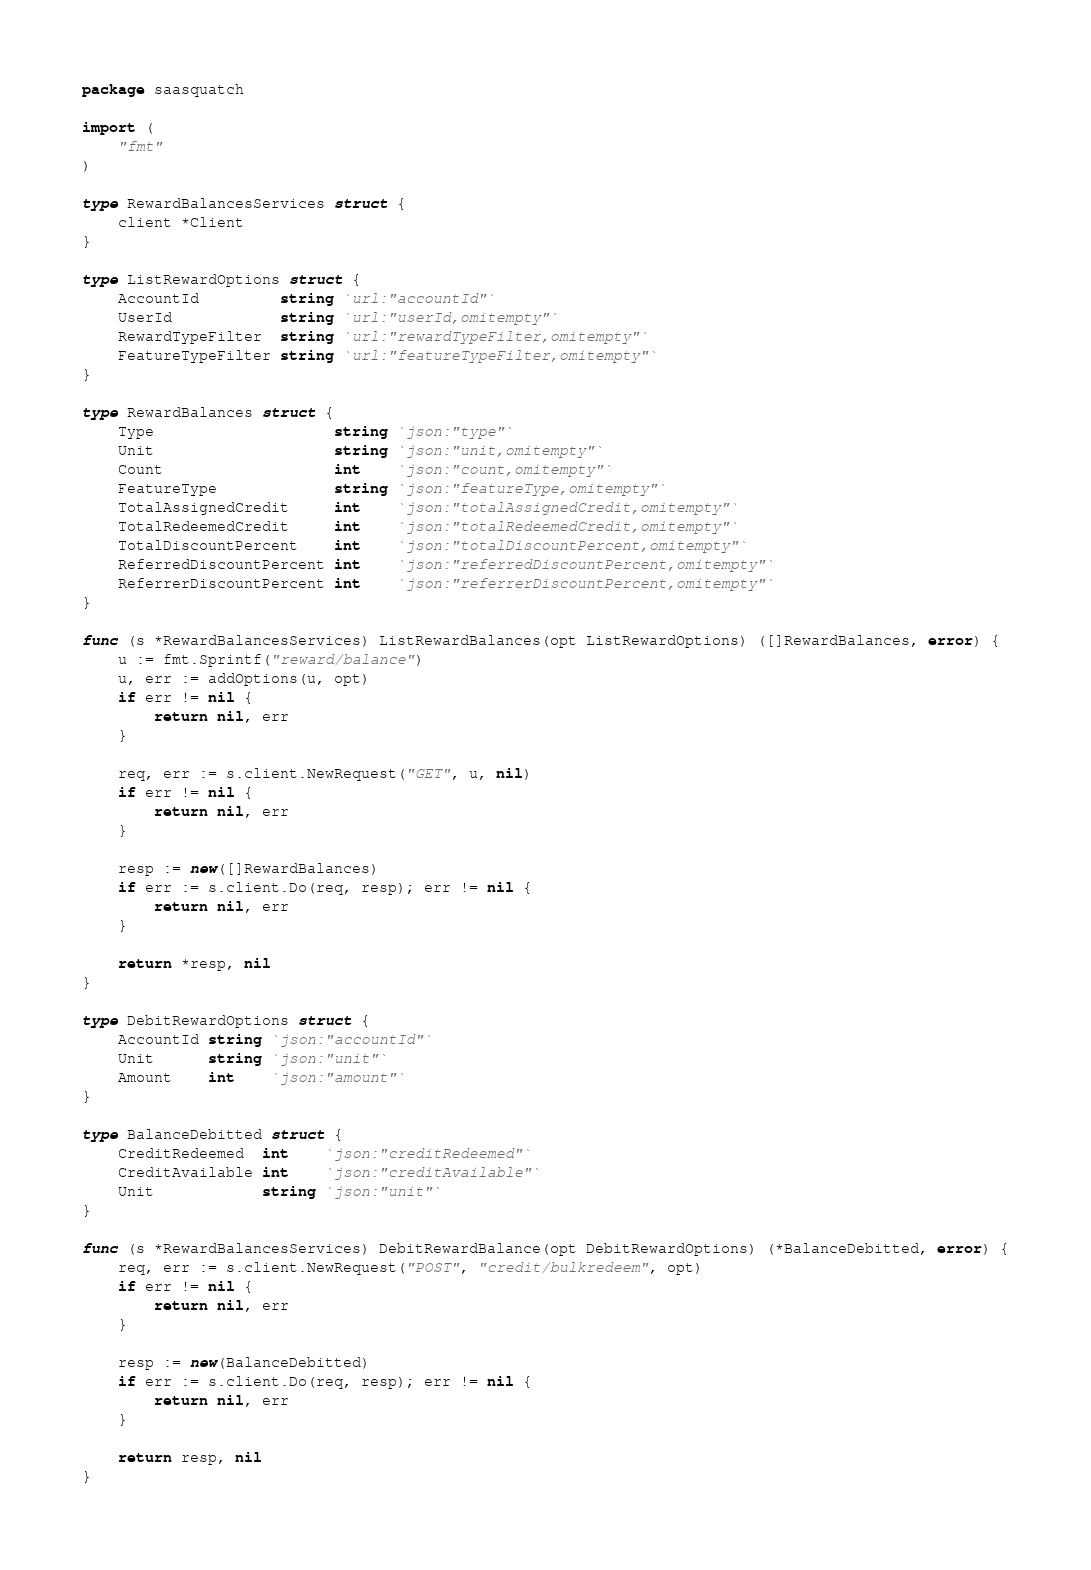Convert code to text. <code><loc_0><loc_0><loc_500><loc_500><_Go_>package saasquatch

import (
	"fmt"
)

type RewardBalancesServices struct {
	client *Client
}

type ListRewardOptions struct {
	AccountId         string `url:"accountId"`
	UserId            string `url:"userId,omitempty"`
	RewardTypeFilter  string `url:"rewardTypeFilter,omitempty"`
	FeatureTypeFilter string `url:"featureTypeFilter,omitempty"`
}

type RewardBalances struct {
	Type                    string `json:"type"`
	Unit                    string `json:"unit,omitempty"`
	Count                   int    `json:"count,omitempty"`
	FeatureType             string `json:"featureType,omitempty"`
	TotalAssignedCredit     int    `json:"totalAssignedCredit,omitempty"`
	TotalRedeemedCredit     int    `json:"totalRedeemedCredit,omitempty"`
	TotalDiscountPercent    int    `json:"totalDiscountPercent,omitempty"`
	ReferredDiscountPercent int    `json:"referredDiscountPercent,omitempty"`
	ReferrerDiscountPercent int    `json:"referrerDiscountPercent,omitempty"`
}

func (s *RewardBalancesServices) ListRewardBalances(opt ListRewardOptions) ([]RewardBalances, error) {
	u := fmt.Sprintf("reward/balance")
	u, err := addOptions(u, opt)
	if err != nil {
		return nil, err
	}

	req, err := s.client.NewRequest("GET", u, nil)
	if err != nil {
		return nil, err
	}

	resp := new([]RewardBalances)
	if err := s.client.Do(req, resp); err != nil {
		return nil, err
	}

	return *resp, nil
}

type DebitRewardOptions struct {
	AccountId string `json:"accountId"`
	Unit      string `json:"unit"`
	Amount    int    `json:"amount"`
}

type BalanceDebitted struct {
	CreditRedeemed  int    `json:"creditRedeemed"`
	CreditAvailable int    `json:"creditAvailable"`
	Unit            string `json:"unit"`
}

func (s *RewardBalancesServices) DebitRewardBalance(opt DebitRewardOptions) (*BalanceDebitted, error) {
	req, err := s.client.NewRequest("POST", "credit/bulkredeem", opt)
	if err != nil {
		return nil, err
	}

	resp := new(BalanceDebitted)
	if err := s.client.Do(req, resp); err != nil {
		return nil, err
	}

	return resp, nil
}
</code> 